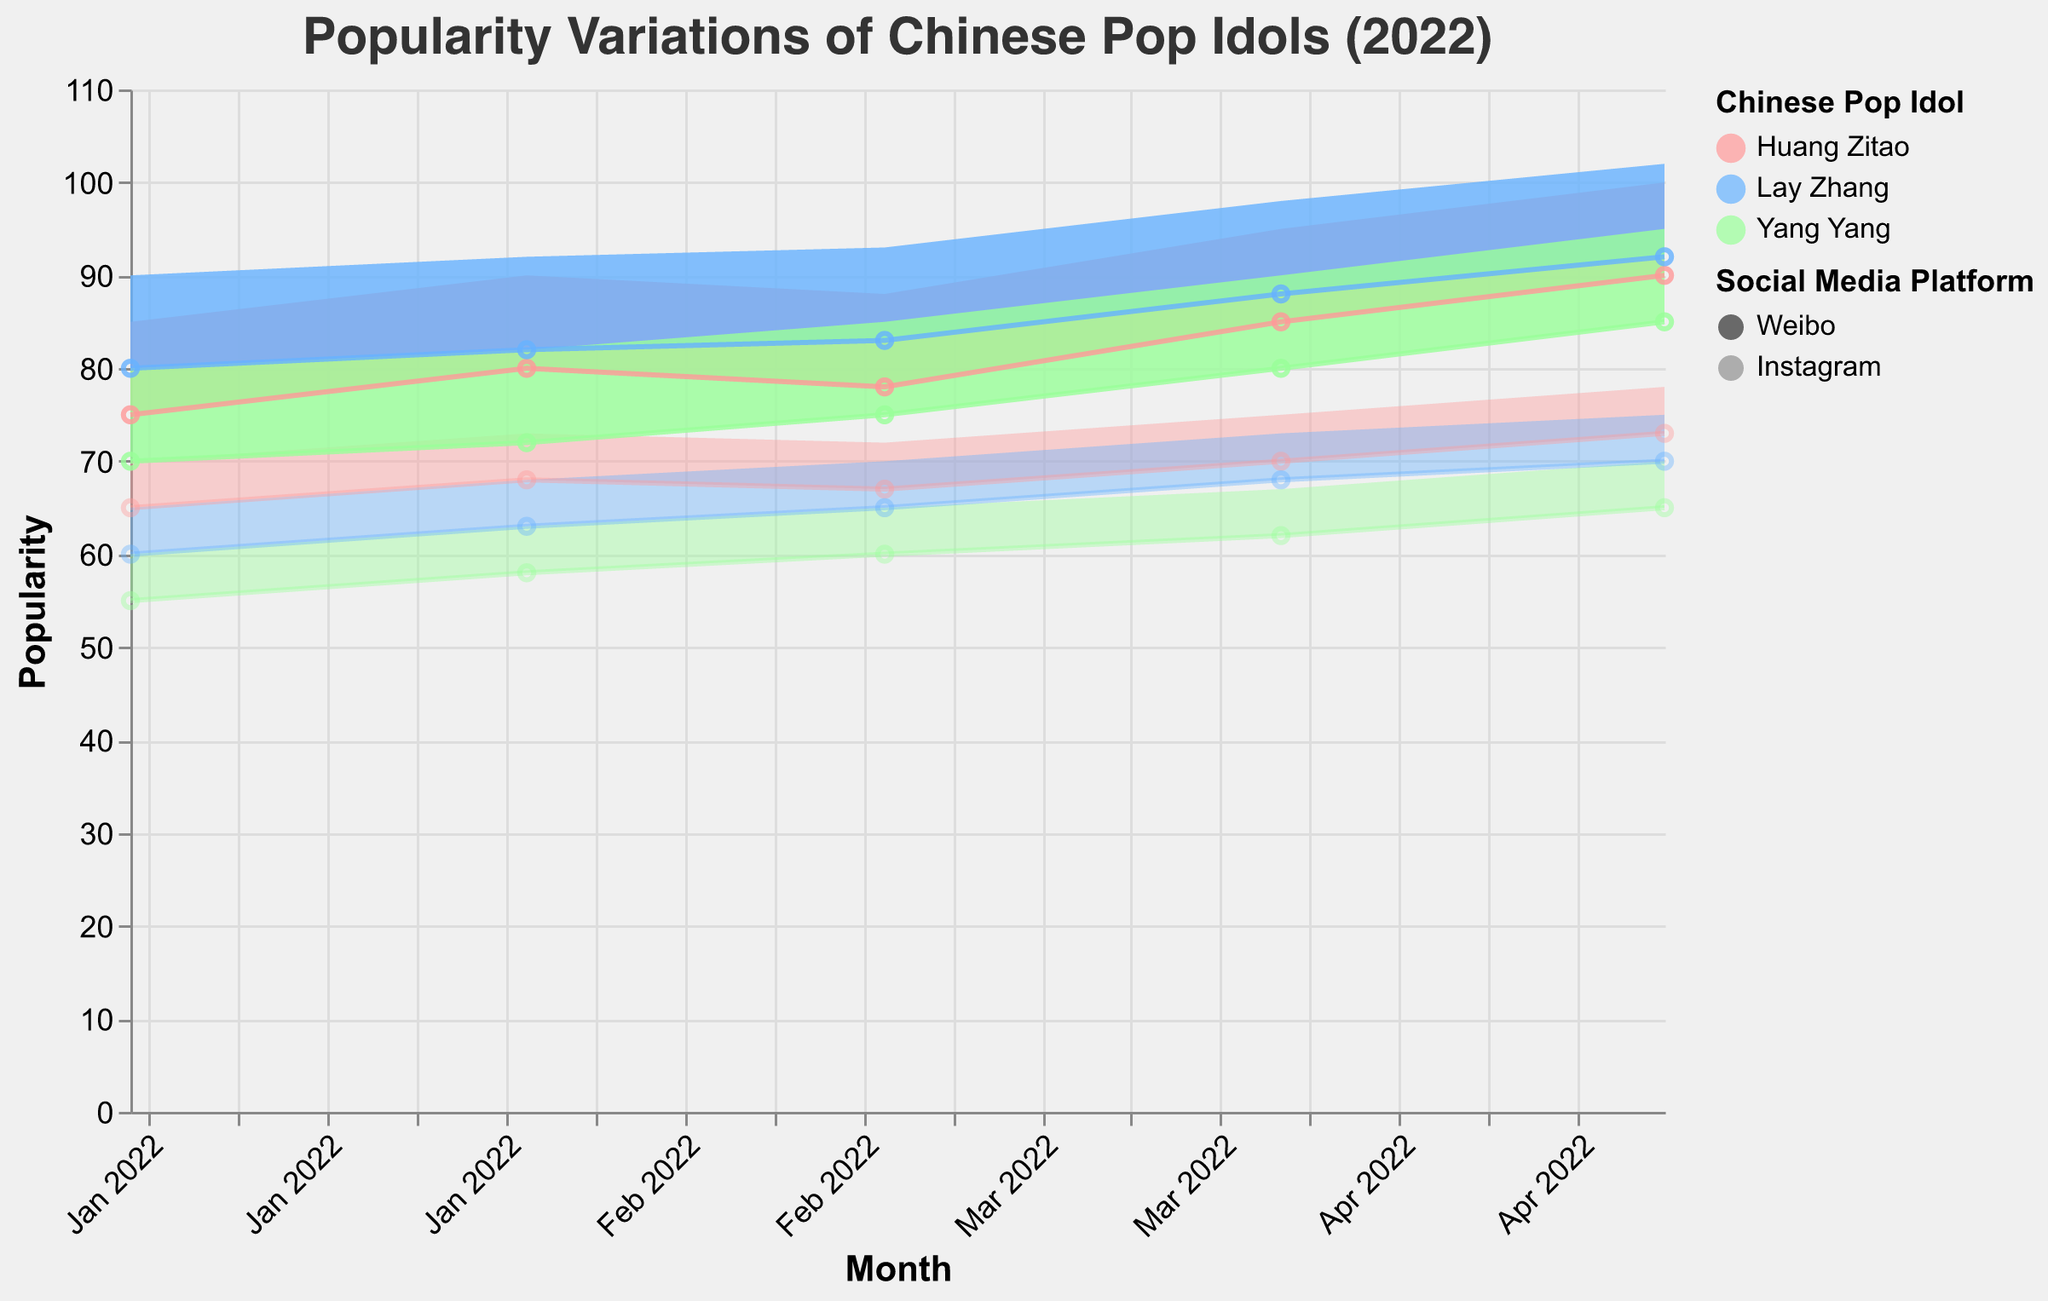How does Huang Zitao's popularity on Weibo change from January to May 2022? Huang Zitao's popularity on Weibo increases from a range of 75-85 in January to 90-100 in May
Answer: It increases Which idol has the highest maximum popularity on Instagram in May 2022? In May 2022, the highest maximum popularity on Instagram is 78, which belongs to Huang Zitao
Answer: Huang Zitao How does the range of Yang Yang's popularity on Weibo compare between March and April 2022? In March 2022, Yang Yang's popularity range on Weibo is 75-85. In April 2022, it is 80-90. Both ranges increase by 5 points, indicating an overall increase
Answer: It increases What is the minimum popularity of Lay Zhang on Instagram in April 2022? In April 2022, the minimum popularity for Lay Zhang on Instagram is 68
Answer: 68 Which platform shows the greatest increase in Huang Zitao's maximum popularity from January to May 2022? On Weibo, Huang Zitao's maximum popularity increases from 85 to 100, while on Instagram, it increases from 70 to 78. The increase on Weibo is 15, which is greater than the 8-point increase on Instagram
Answer: Weibo What is the overall trend for all three idols' popularity on Weibo from January to May 2022? All three idols show an increasing trend in their popularity on Weibo over the months, with minimum and maximum values both rising
Answer: Increasing Compare the popularity range of Lay Zhang on Instagram and Weibo in February 2022. In February 2022, Lay Zhang's popularity range on Instagram is 63-68, while on Weibo it is 82-92. The range on Weibo is much higher
Answer: Weibo has a higher range What is the average maximum popularity of Yang Yang across all platforms in March 2022? For Weibo: 85, Instagram: 65. Average maximum popularity = (85+65)/2 = 75
Answer: 75 During which month did Lay Zhang have the highest minimum popularity on Weibo? Lay Zhang's highest minimum popularity on Weibo is 92, which occurs in May 2022
Answer: May 2022 